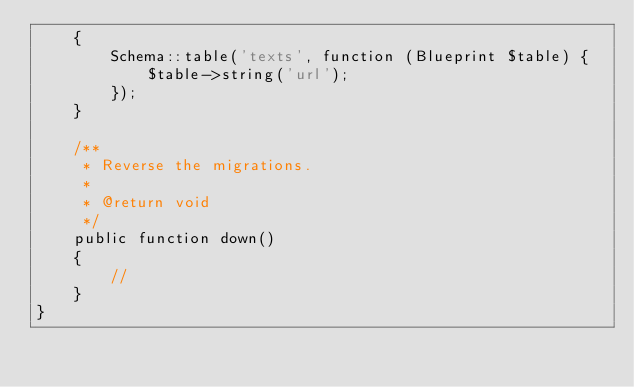<code> <loc_0><loc_0><loc_500><loc_500><_PHP_>    {
        Schema::table('texts', function (Blueprint $table) {
            $table->string('url');
        });
    }

    /**
     * Reverse the migrations.
     *
     * @return void
     */
    public function down()
    {
        //
    }
}
</code> 